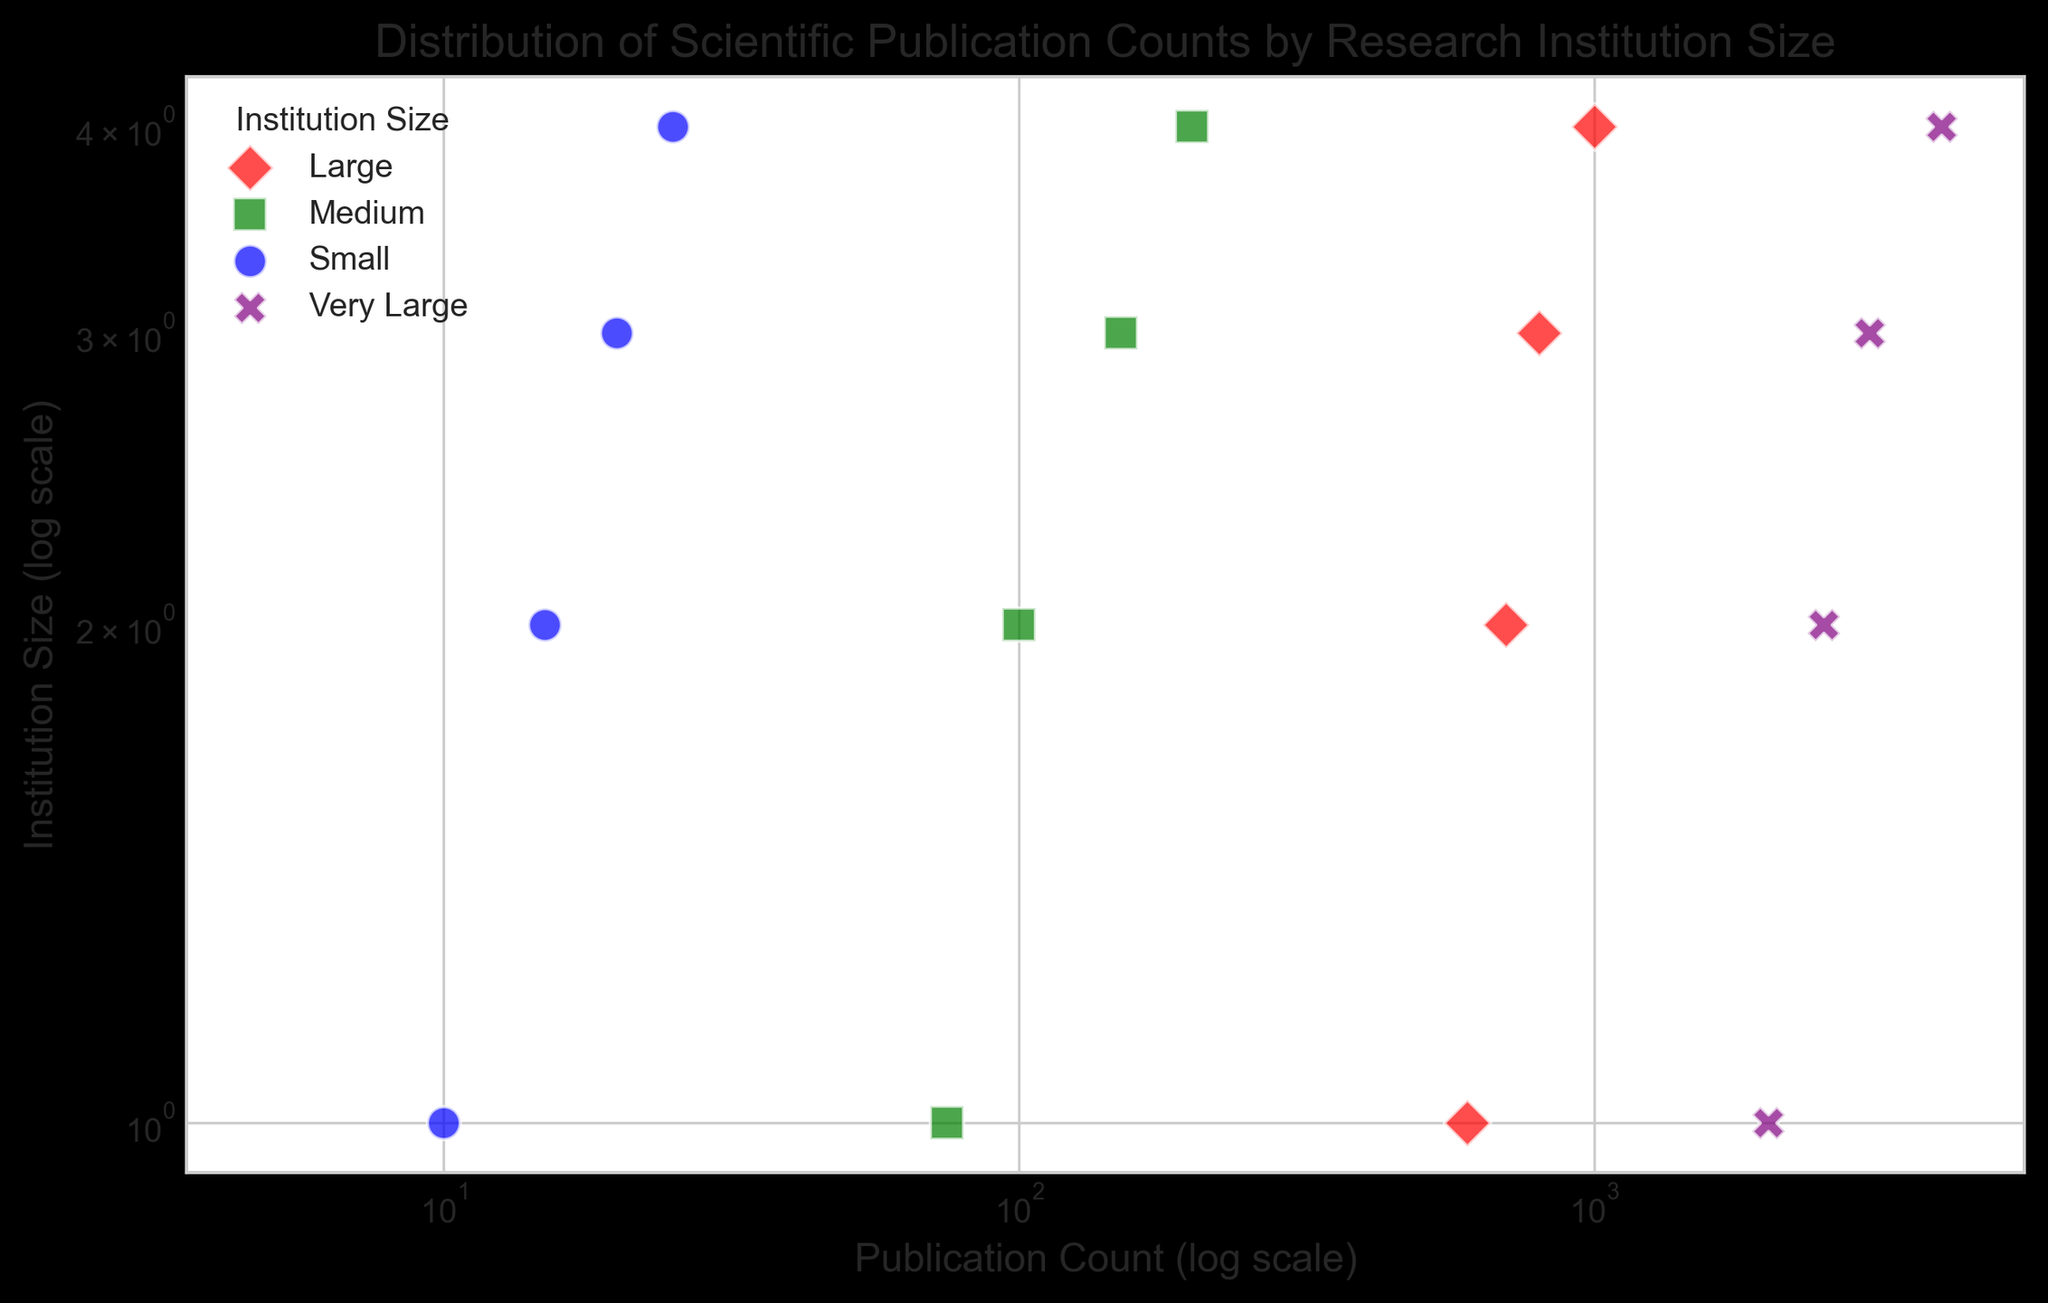Which institution size group has the highest publication count? The "Very Large" group has the highest publication count, reaching up to 4000 publications. This is evident from their purple markers being farther along the x-axis.
Answer: Very Large How does the publication count of "Medium" institutions compare to "Large" institutions? Medium institutions have a publication count ranging from 50 to 200, while Large institutions range from 500 to 1000. Therefore, Large institutions have higher publication counts than Medium institutions.
Answer: Large institutions have higher publication counts Which color represents the "Small" institution group, and what is its publication count range? The "Small" institution group is represented by blue markers, and the publication count ranges from 5 to 25 publications. This can be seen by the placement of the blue markers on the x-axis.
Answer: Blue, 5 to 25 What is the difference between the highest publication count of "Small" and "Very Large" institutions? The highest publication count for "Small" institutions is 25, and for "Very Large" institutions, it is 4000. The difference is 4000 - 25 = 3975.
Answer: 3975 What do the markers "o", "s", "D", and "X" represent in the figure? The markers represent different institution sizes: "o" for Small, "s" for Medium, "D" for Large, and "X" for Very Large. This is displayed in the legend on the upper left corner of the plot.
Answer: Institution sizes How many institution size groups are represented on the chart and what are they? There are four institution size groups on the chart: Small, Medium, Large, and Very Large. This is indicated by the four different markers and colors in the scatter plot.
Answer: Four groups: Small, Medium, Large, Very Large 